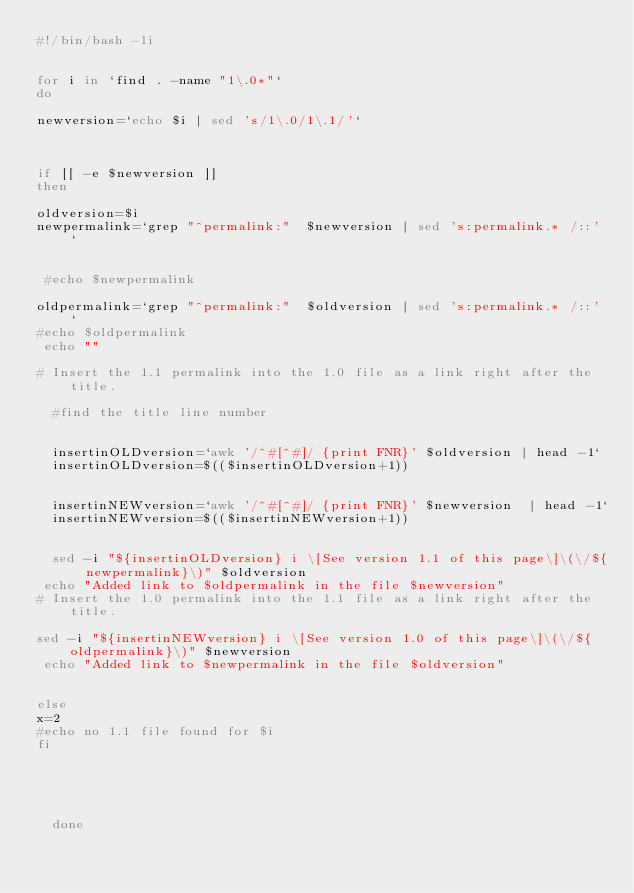Convert code to text. <code><loc_0><loc_0><loc_500><loc_500><_Bash_>#!/bin/bash -li


for i in `find . -name "1\.0*"` 
do

newversion=`echo $i | sed 's/1\.0/1\.1/'`

 

if [[ -e $newversion ]]
then
 
oldversion=$i
newpermalink=`grep "^permalink:"  $newversion | sed 's:permalink.* /::' `


 #echo $newpermalink

oldpermalink=`grep "^permalink:"  $oldversion | sed 's:permalink.* /::' `
#echo $oldpermalink
 echo ""
 
#	Insert the 1.1 permalink into the 1.0 file as a link right after the title.

	#find the title line number

 
	insertinOLDversion=`awk '/^#[^#]/ {print FNR}' $oldversion | head -1`
	insertinOLDversion=$(($insertinOLDversion+1))
	
 
	insertinNEWversion=`awk '/^#[^#]/ {print FNR}' $newversion  | head -1`
	insertinNEWversion=$(($insertinNEWversion+1))

 
	sed -i "${insertinOLDversion} i \[See version 1.1 of this page\]\(\/${newpermalink}\)" $oldversion 
 echo "Added link to $oldpermalink in the file $newversion"
#	Insert the 1.0 permalink into the 1.1 file as a link right after the title.

sed -i "${insertinNEWversion} i \[See version 1.0 of this page\]\(\/${oldpermalink}\)" $newversion 
 echo "Added link to $newpermalink in the file $oldversion"
	 

else
x=2 
#echo no 1.1 file found for $i
fi

 


	
	done</code> 